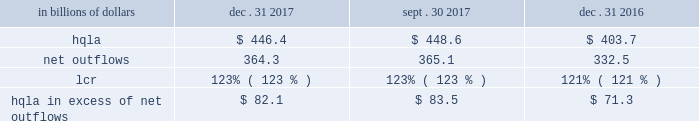Liquidity monitoring and measurement stress testing liquidity stress testing is performed for each of citi 2019s major entities , operating subsidiaries and/or countries .
Stress testing and scenario analyses are intended to quantify the potential impact of an adverse liquidity event on the balance sheet and liquidity position , and to identify viable funding alternatives that can be utilized .
These scenarios include assumptions about significant changes in key funding sources , market triggers ( such as credit ratings ) , potential uses of funding and geopolitical and macroeconomic conditions .
These conditions include expected and stressed market conditions as well as company-specific events .
Liquidity stress tests are conducted to ascertain potential mismatches between liquidity sources and uses over a variety of time horizons and over different stressed conditions .
Liquidity limits are set accordingly .
To monitor the liquidity of an entity , these stress tests and potential mismatches are calculated with varying frequencies , with several tests performed daily .
Given the range of potential stresses , citi maintains contingency funding plans on a consolidated basis and for individual entities .
These plans specify a wide range of readily available actions for a variety of adverse market conditions or idiosyncratic stresses .
Short-term liquidity measurement : liquidity coverage ratio ( lcr ) in addition to internal liquidity stress metrics that citi has developed for a 30-day stress scenario , citi also monitors its liquidity by reference to the lcr , as calculated pursuant to the u.s .
Lcr rules .
Generally , the lcr is designed to ensure that banks maintain an adequate level of hqla to meet liquidity needs under an acute 30-day stress scenario .
The lcr is calculated by dividing hqla by estimated net outflows over a stressed 30-day period , with the net outflows determined by applying prescribed outflow factors to various categories of liabilities , such as deposits , unsecured and secured wholesale borrowings , unused lending commitments and derivatives- related exposures , partially offset by inflows from assets maturing within 30 days .
Banks are required to calculate an add-on to address potential maturity mismatches between contractual cash outflows and inflows within the 30-day period in determining the total amount of net outflows .
The minimum lcr requirement is 100% ( 100 % ) , effective january 2017 .
Pursuant to the federal reserve board 2019s final rule regarding lcr disclosures , effective april 1 , 2017 , citi began to disclose lcr in the prescribed format .
The table below sets forth the components of citi 2019s lcr calculation and hqla in excess of net outflows for the periods indicated : in billions of dollars dec .
31 , sept .
30 , dec .
31 .
Note : amounts set forth in the table above are presented on an average basis .
As set forth in the table above , citi 2019s lcr increased year- over-year , as the increase in the hqla ( as discussed above ) more than offset an increase in modeled net outflows .
The increase in modeled net outflows was primarily driven by changes in assumptions , including changes in methodology to better align citi 2019s outflow assumptions with those embedded in its resolution planning .
Sequentially , citi 2019s lcr remained unchanged .
Long-term liquidity measurement : net stable funding ratio ( nsfr ) in 2016 , the federal reserve board , the fdic and the occ issued a proposed rule to implement the basel iii nsfr requirement .
The u.s.-proposed nsfr is largely consistent with the basel committee 2019s final nsfr rules .
In general , the nsfr assesses the availability of a bank 2019s stable funding against a required level .
A bank 2019s available stable funding would include portions of equity , deposits and long-term debt , while its required stable funding would be based on the liquidity characteristics of its assets , derivatives and commitments .
Prescribed factors would be required to be applied to the various categories of asset and liabilities classes .
The ratio of available stable funding to required stable funding would be required to be greater than 100% ( 100 % ) .
While citi believes that it is compliant with the proposed u.s .
Nsfr rules as of december 31 , 2017 , it will need to evaluate a final version of the rules , which are expected to be released during 2018 .
Citi expects that the nsfr final rules implementation period will be communicated along with the final version of the rules. .
What was the percentage increase in the net outflows from 2016 to 2017? 
Computations: ((364.3 - 332.5) / 332.5)
Answer: 0.09564. 